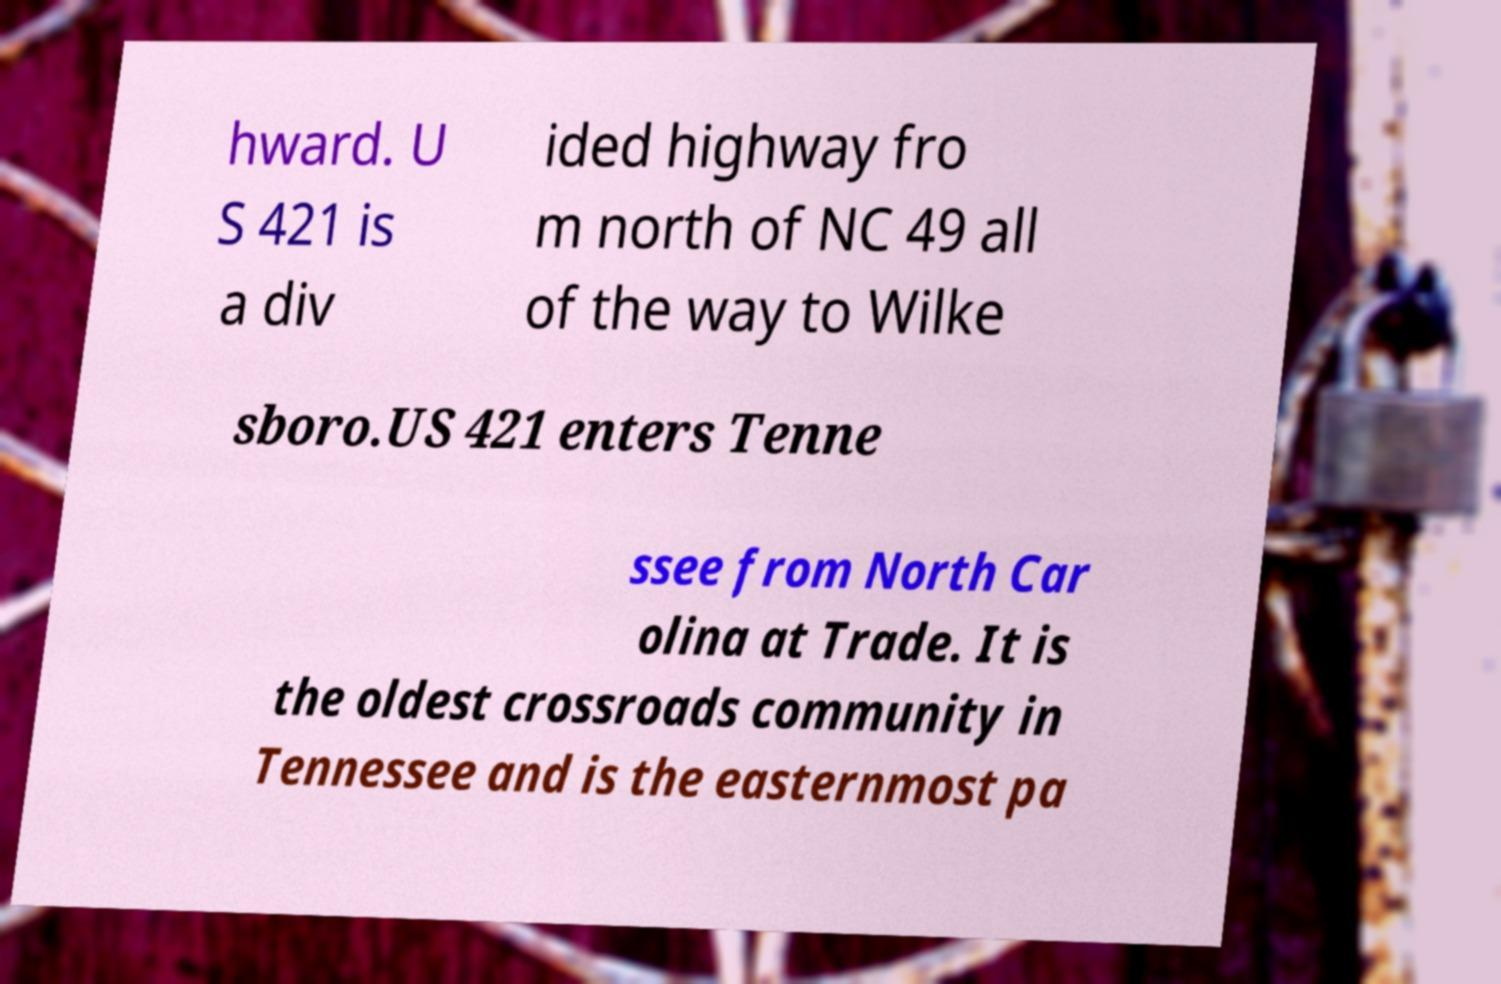Could you extract and type out the text from this image? hward. U S 421 is a div ided highway fro m north of NC 49 all of the way to Wilke sboro.US 421 enters Tenne ssee from North Car olina at Trade. It is the oldest crossroads community in Tennessee and is the easternmost pa 